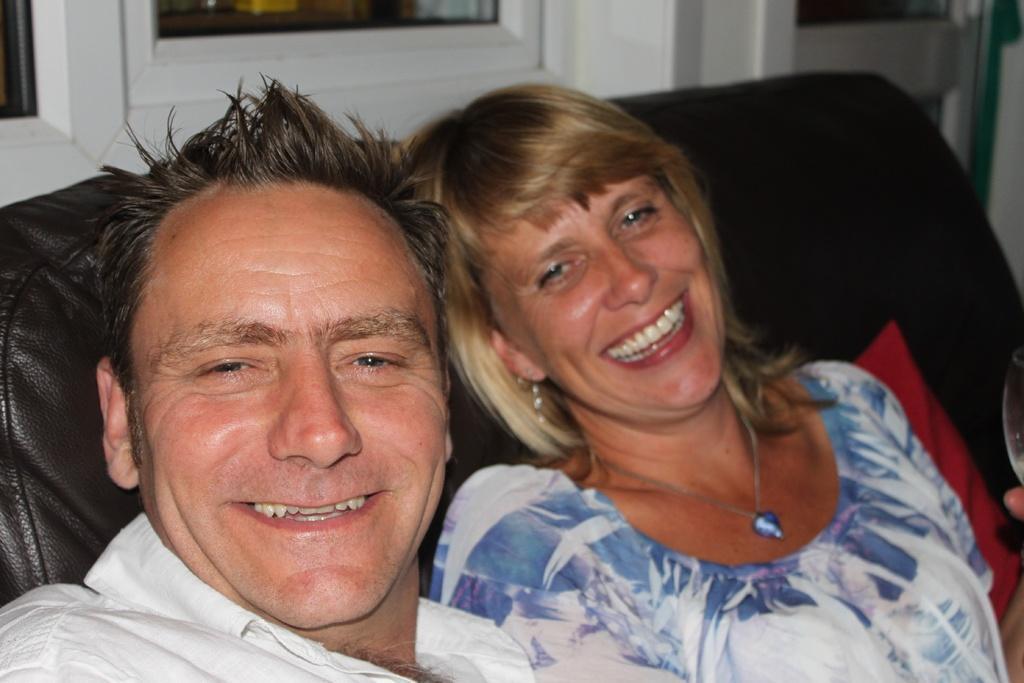Can you describe this image briefly? In this image, we can see two people sitting on the sofa, in the background we can see white color windows. 